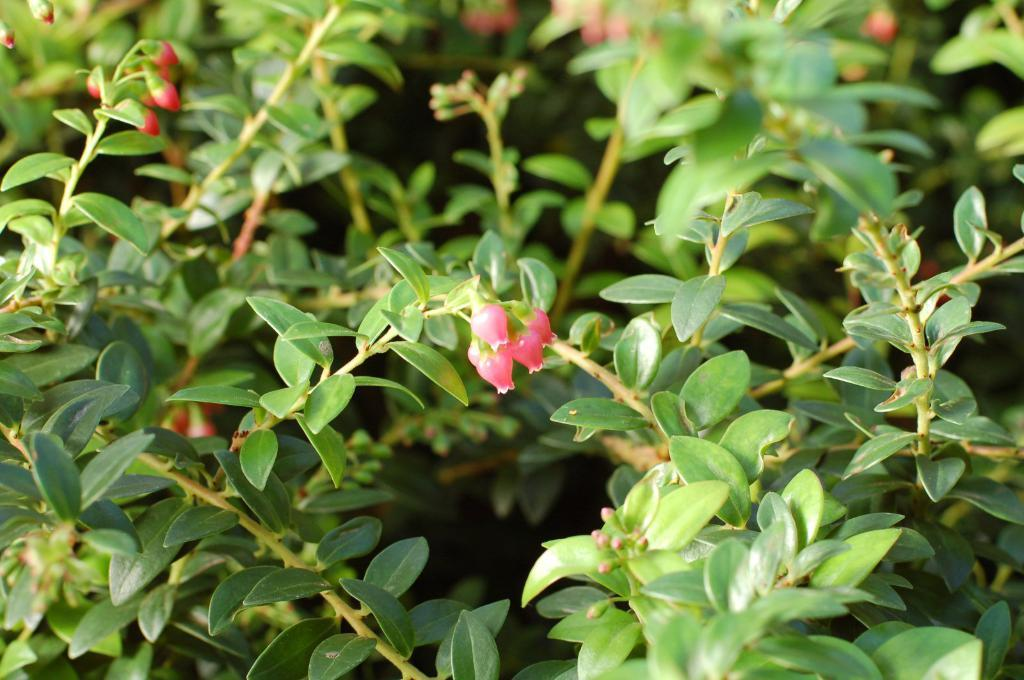What type of living organisms can be seen in the image? Plants can be seen in the image. What stage of growth are the plants in? There are buds on the plants, indicating that they are in the early stages of growth. How does the beginner handle the expert in the image? There is no reference to a beginner or an expert in the image; it only features plants with buds. 